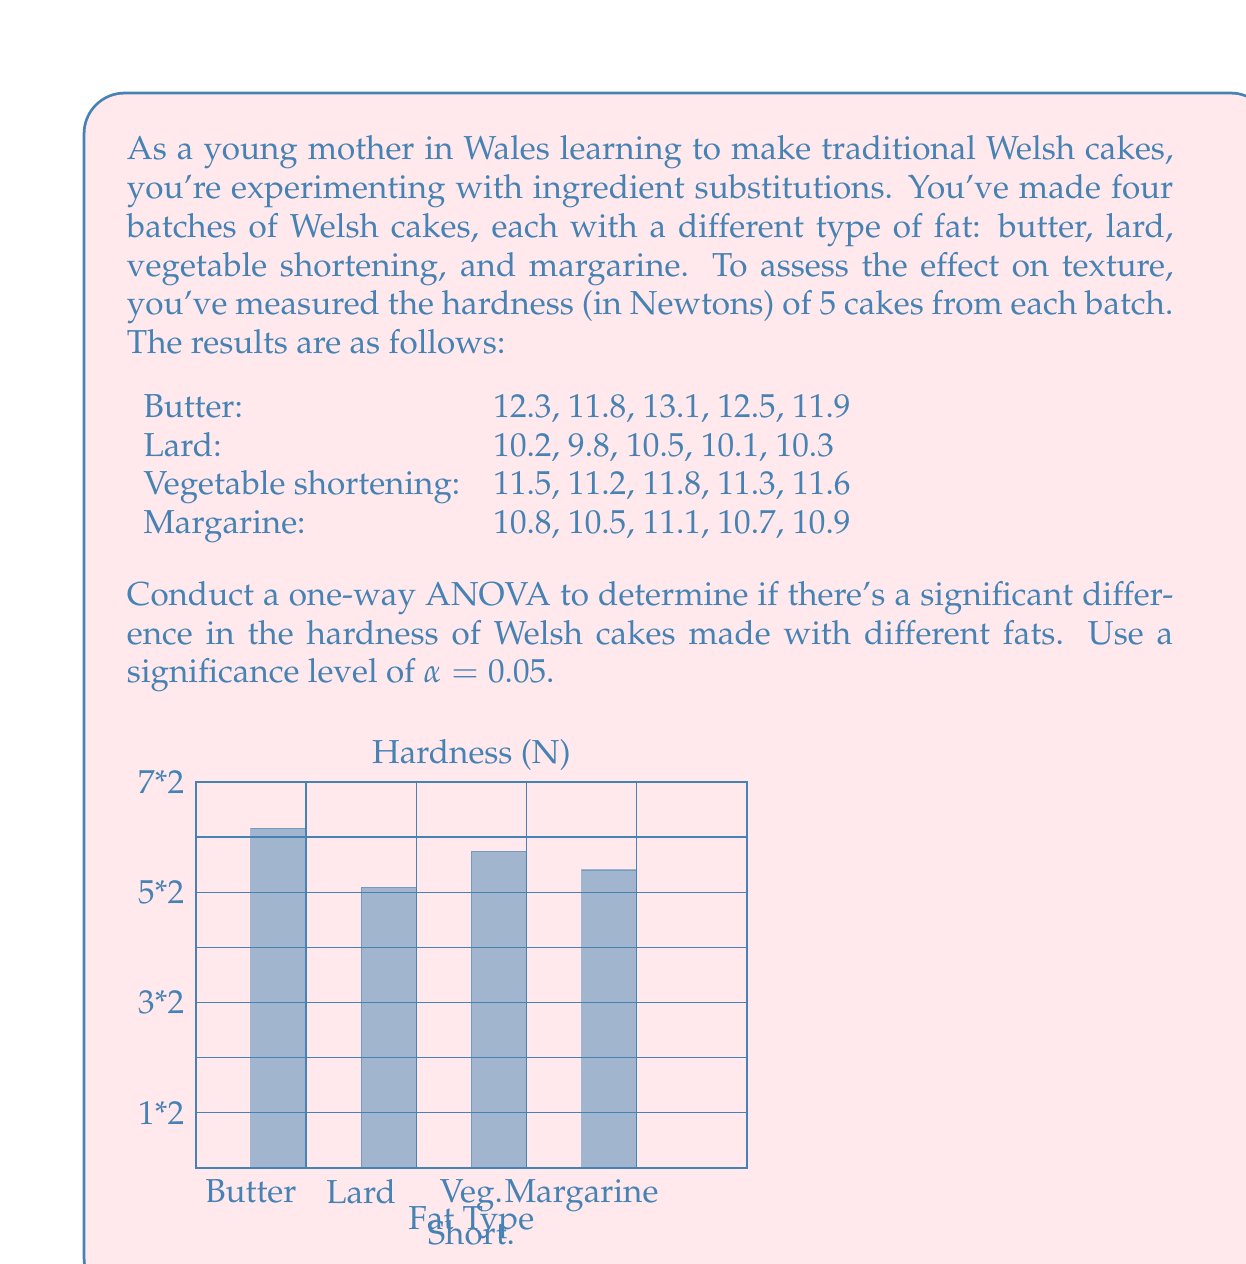What is the answer to this math problem? To conduct a one-way ANOVA, we'll follow these steps:

1. Calculate the sum of squares between groups (SSB) and within groups (SSW).
2. Calculate the degrees of freedom for between groups (dfB) and within groups (dfW).
3. Calculate the mean squares between groups (MSB) and within groups (MSW).
4. Calculate the F-statistic.
5. Compare the F-statistic to the critical F-value.

Step 1: Calculate SSB and SSW

First, we need to calculate the grand mean:
$$ \bar{X} = \frac{(12.3 + 11.8 + ... + 10.9)}{20} = 11.195 $$

Now, we calculate SSB:
$$ SSB = 5[(12.32 - 11.195)^2 + (10.18 - 11.195)^2 + (11.48 - 11.195)^2 + (10.8 - 11.195)^2] = 16.7845 $$

For SSW, we calculate the sum of squared deviations within each group:
$$ SSW = [(12.3 - 12.32)^2 + ... + (10.9 - 10.8)^2] = 1.638 $$

Step 2: Calculate degrees of freedom

$$ df_B = k - 1 = 4 - 1 = 3 $$
$$ df_W = N - k = 20 - 4 = 16 $$

where k is the number of groups and N is the total number of observations.

Step 3: Calculate mean squares

$$ MSB = \frac{SSB}{df_B} = \frac{16.7845}{3} = 5.5948 $$
$$ MSW = \frac{SSW}{df_W} = \frac{1.638}{16} = 0.1024 $$

Step 4: Calculate F-statistic

$$ F = \frac{MSB}{MSW} = \frac{5.5948}{0.1024} = 54.64 $$

Step 5: Compare to critical F-value

The critical F-value for α = 0.05, df_B = 3, and df_W = 16 is approximately 3.24.

Since our calculated F-statistic (54.64) is greater than the critical F-value (3.24), we reject the null hypothesis.
Answer: Reject null hypothesis; significant difference in hardness (F(3,16) = 54.64, p < 0.05) 